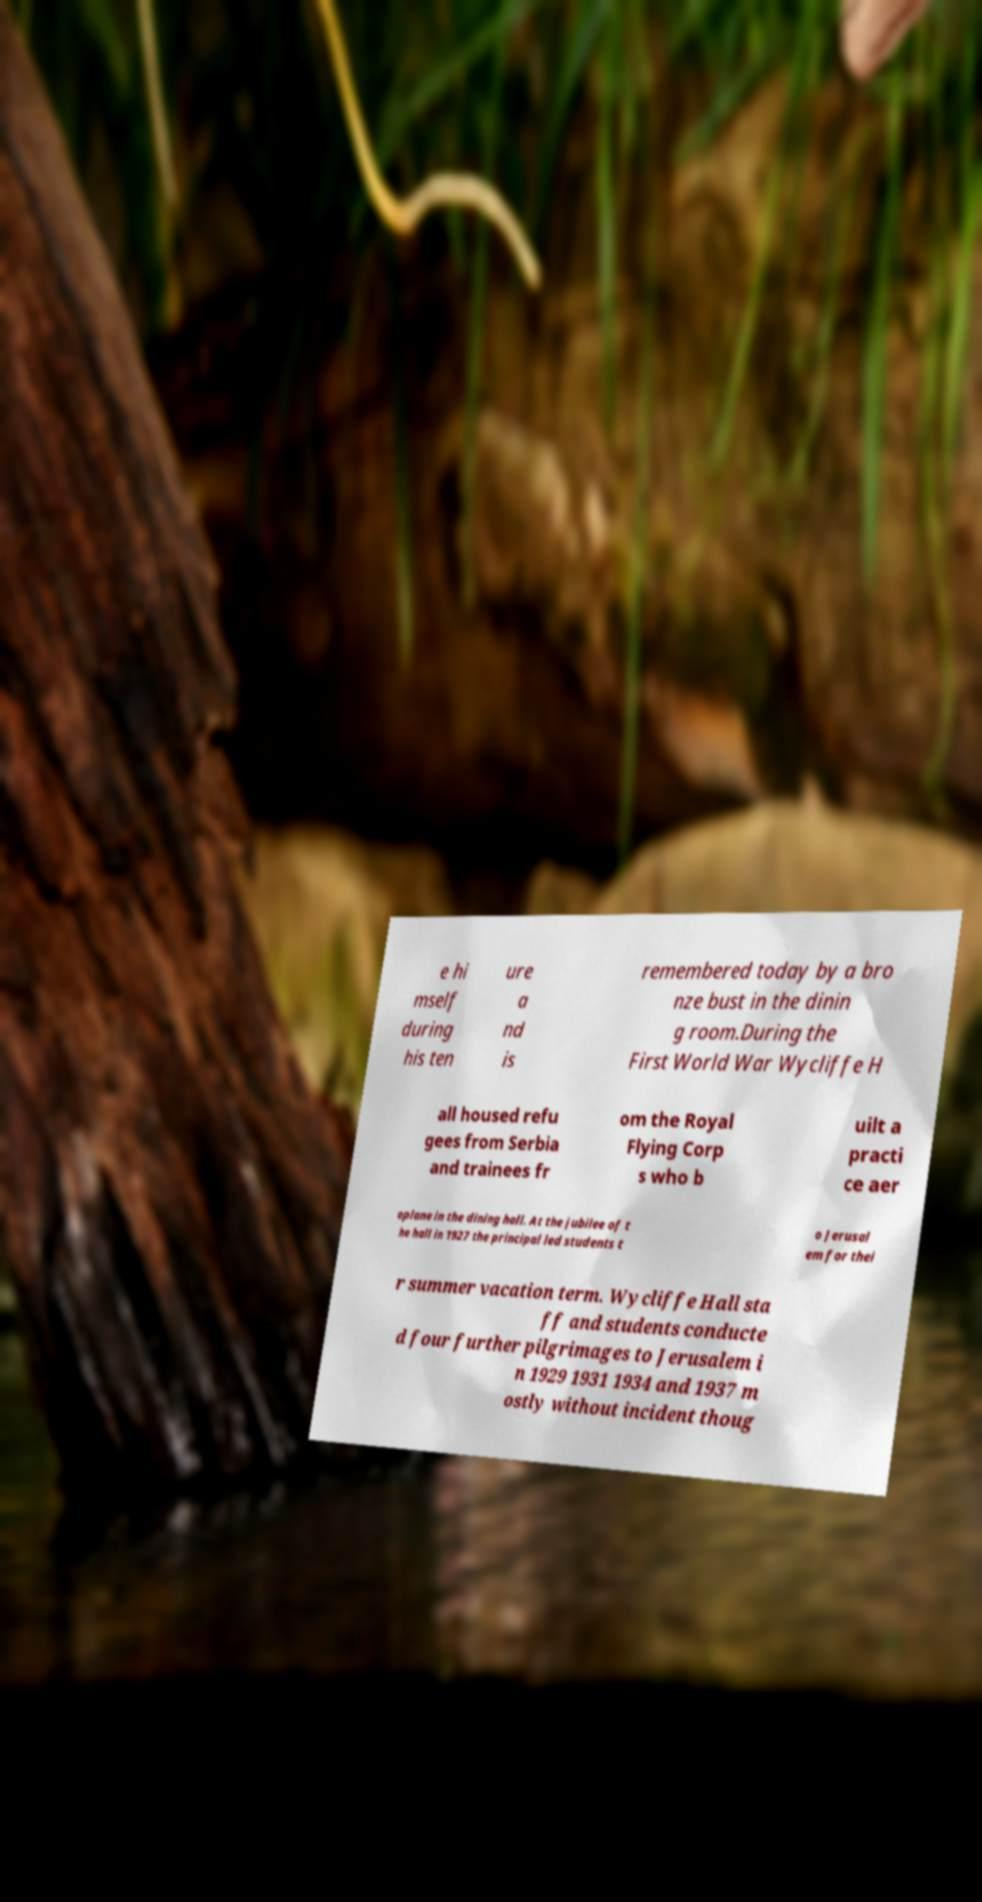For documentation purposes, I need the text within this image transcribed. Could you provide that? e hi mself during his ten ure a nd is remembered today by a bro nze bust in the dinin g room.During the First World War Wycliffe H all housed refu gees from Serbia and trainees fr om the Royal Flying Corp s who b uilt a practi ce aer oplane in the dining hall. At the jubilee of t he hall in 1927 the principal led students t o Jerusal em for thei r summer vacation term. Wycliffe Hall sta ff and students conducte d four further pilgrimages to Jerusalem i n 1929 1931 1934 and 1937 m ostly without incident thoug 